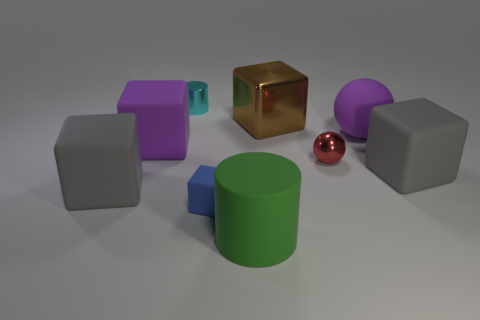Is the number of purple spheres that are in front of the small red sphere greater than the number of purple blocks that are in front of the green matte cylinder?
Your answer should be compact. No. Does the object in front of the tiny blue rubber object have the same material as the gray cube that is on the left side of the green matte thing?
Offer a terse response. Yes. What shape is the cyan thing that is the same size as the red metallic ball?
Your response must be concise. Cylinder. Is there a big green object that has the same shape as the large brown metallic thing?
Offer a terse response. No. Is the color of the tiny metallic thing to the left of the small blue object the same as the big rubber thing that is to the right of the large purple ball?
Offer a terse response. No. Are there any small metallic objects left of the tiny cyan cylinder?
Give a very brief answer. No. There is a object that is both right of the purple block and left of the small blue matte thing; what is its material?
Your answer should be compact. Metal. Is the material of the gray thing to the right of the blue cube the same as the tiny cylinder?
Give a very brief answer. No. What is the material of the big green object?
Ensure brevity in your answer.  Rubber. There is a cylinder that is behind the big brown metal block; how big is it?
Give a very brief answer. Small. 